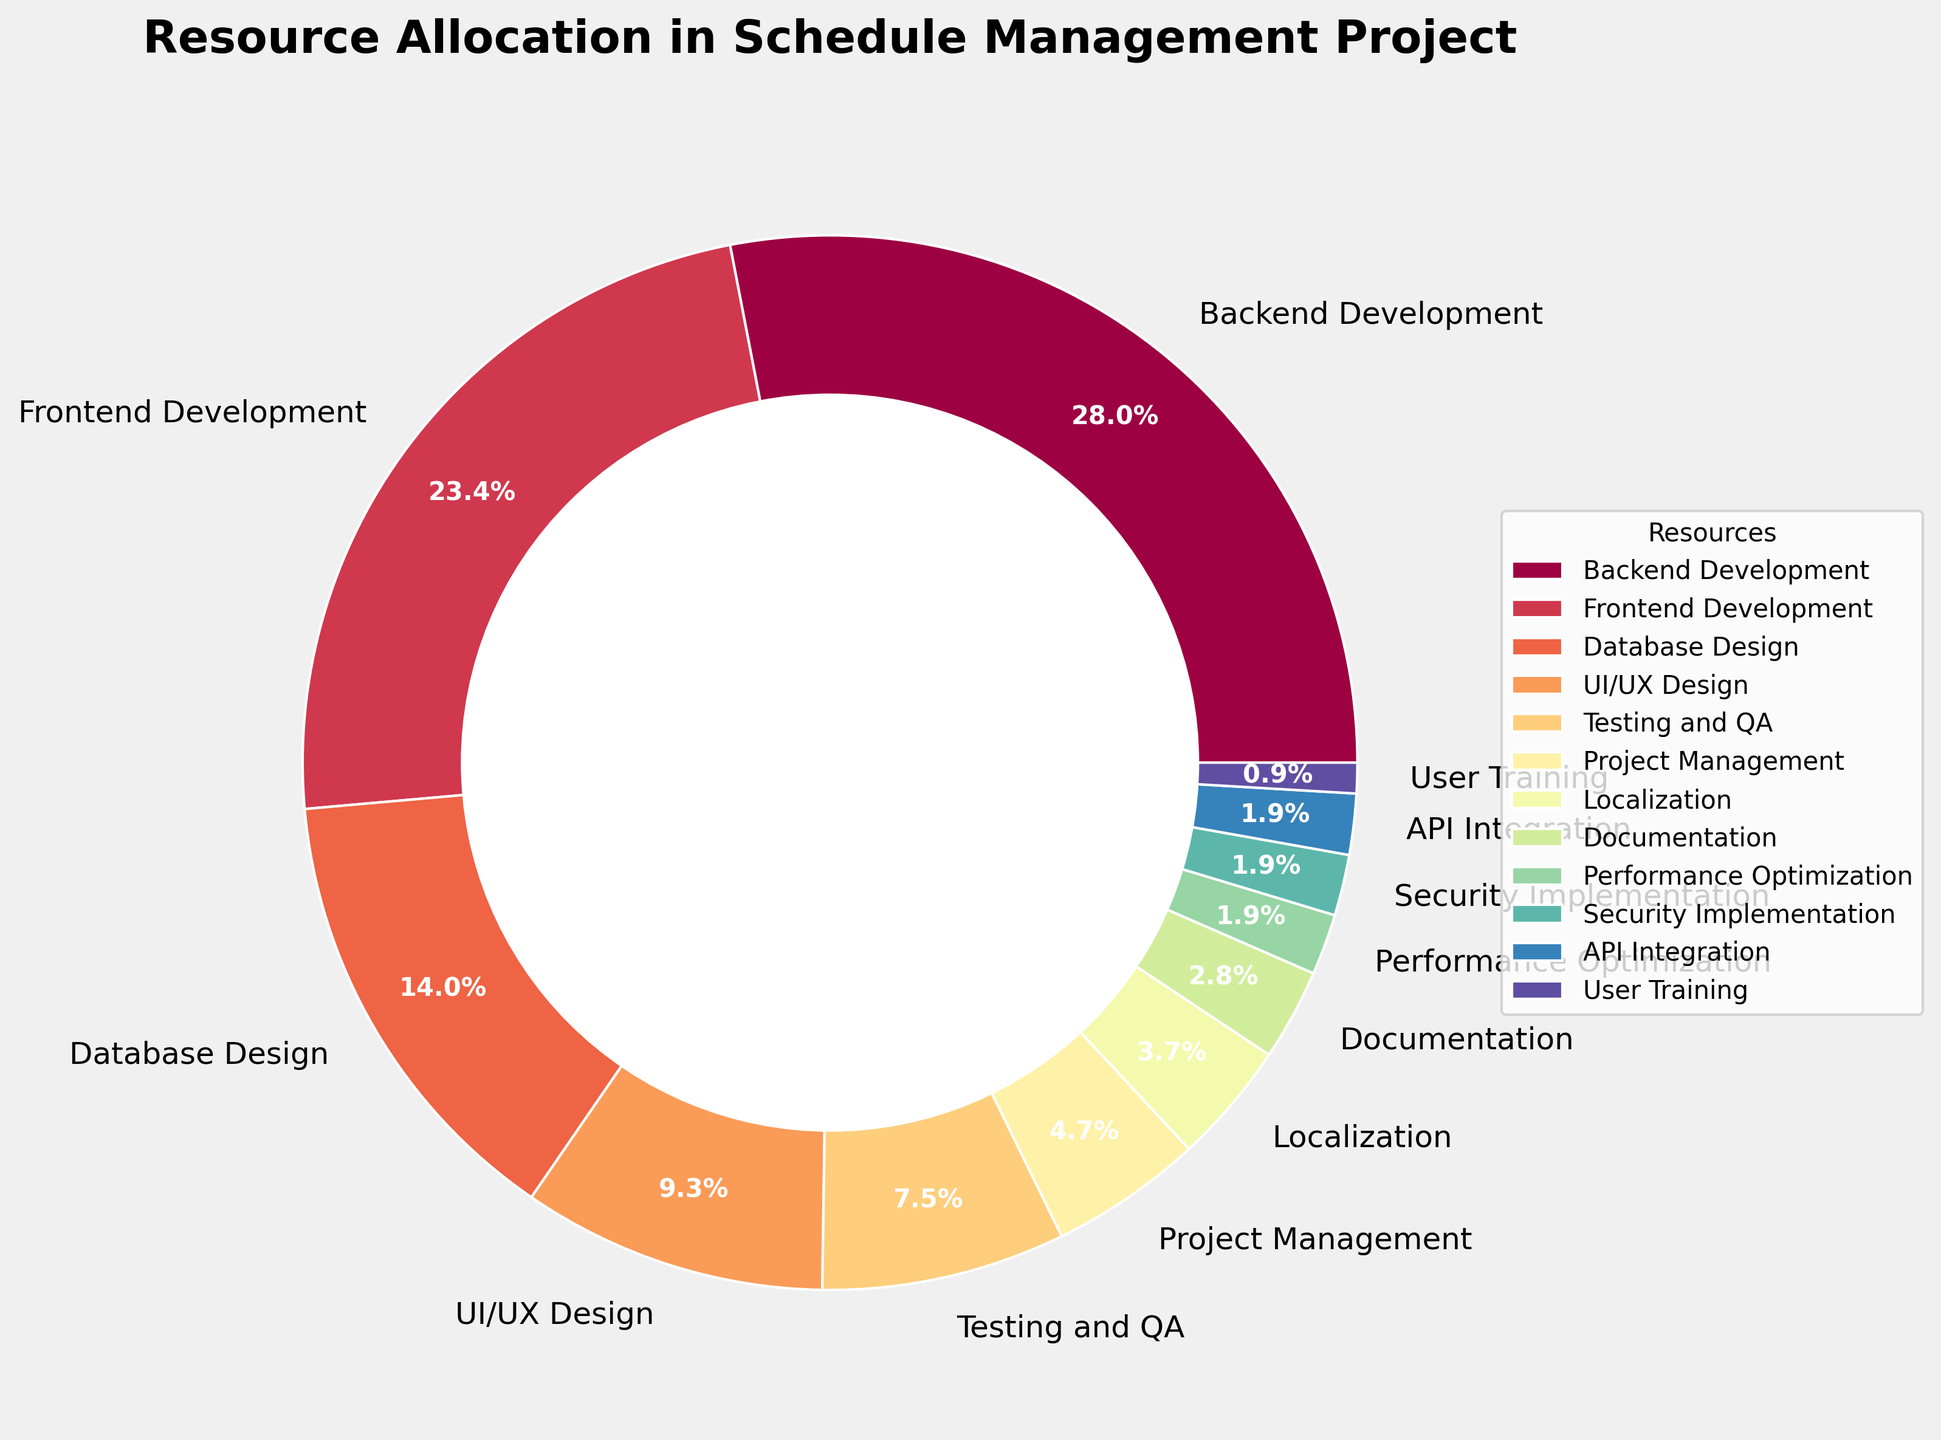What resource takes up the largest percentage? To find the largest percentage, identify the resource with the highest value from the pie chart, which is Backend Development at 30%.
Answer: Backend Development Which three resources have the smallest percentages, and what are their combined total? Identify the resources with the smallest percentages from the pie chart: User Training (1%), Performance Optimization (2%), Security Implementation (2%), and API Integration (2%). Combine the three smallest: User Training (1%), Security Implementation (2%), and API Integration (2%). Their combined total is 1% + 2% + 2% = 5%.
Answer: User Training, Security Implementation, and API Integration; 5% What is the cumulative percentage for UI/UX Design, Testing and QA, and Project Management? Add the percentages of UI/UX Design (10%), Testing and QA (8%), and Project Management (5%): 10% + 8% + 5% = 23%.
Answer: 23% How does the percentage for Backend Development compare to the percentage for Database Design? Compare the two percentages: Backend Development (30%) and Database Design (15%). 30% is greater than 15%.
Answer: Backend Development > Database Design What is the percentage difference between Frontend Development and Testing and QA? Subtract the percentage of Testing and QA (8%) from Frontend Development (25%): 25% - 8% = 17%.
Answer: 17% Which section is visually the smallest and how much of the total pie does it represent? Identify the smallest section visually on the pie chart, which corresponds to User Training at 1%.
Answer: User Training; 1% What color represents the Database Design section in the pie chart? Observe the pie chart and identify the color associated with Database Design. This would typically need to be interpreted from the chart visualization.
Answer: (Insert color based on the visual) Are there any sections in the pie chart that have equal percentages? If so, which ones? Identify if any sections have equal percentages from the data. Performance Optimization (2%), Security Implementation (2%), and API Integration (2%) are equal.
Answer: Performance Optimization, Security Implementation, and API Integration Is the total percentage allocated to all resources accurately represented? Sum all the percentage values from the chart to ensure they equal 100%. Adding them: 30% + 25% + 15% + 10% + 8% + 5% + 4% + 3% + 2% + 2% + 2% + 1% = 100%.
Answer: Yes, 100% If you combine the percentages of the least allocated resources (User Training, API Integration, Security Implementation, and Performance Optimization), what percentage of the total pie does it represent? Add the percentages of User Training (1%), API Integration (2%), Security Implementation (2%), and Performance Optimization (2%): 1% + 2% + 2% + 2% = 7%.
Answer: 7% 